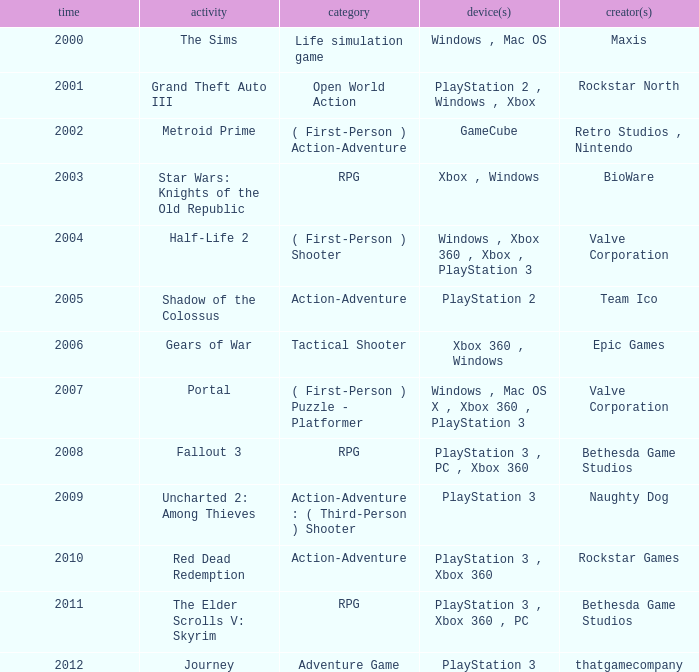What game was in 2001? Grand Theft Auto III. 